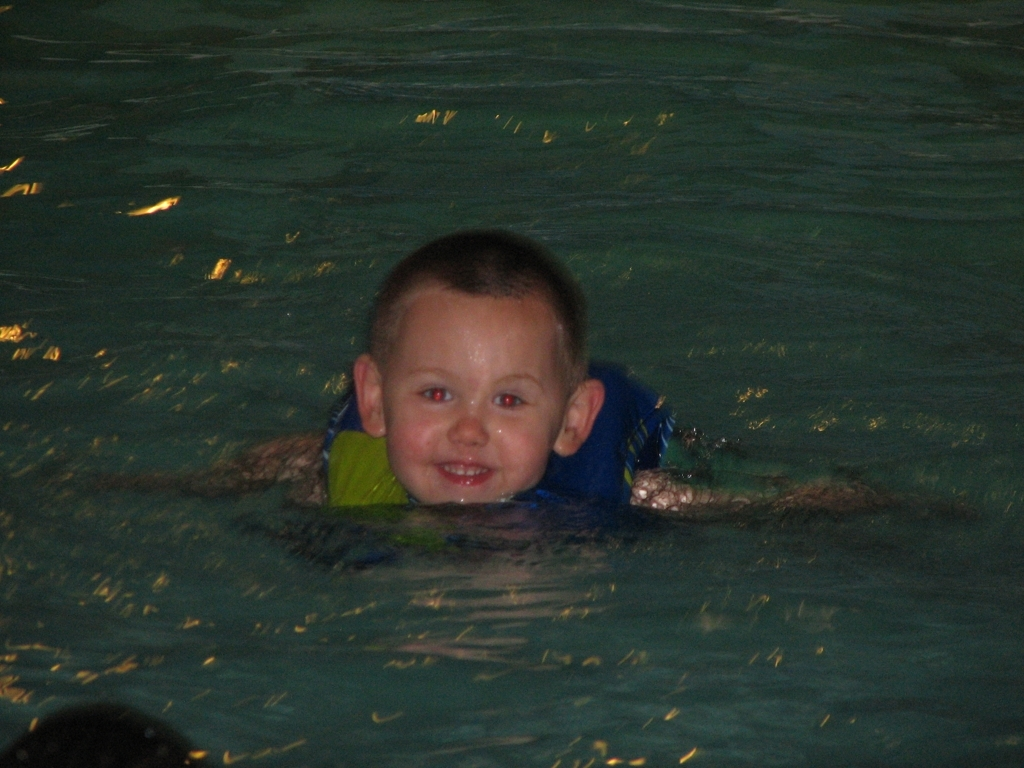How important is it for children to learn swimming at an early age? Learning to swim at an early age is very important for safety, as it equips children with vital survival skills in water. Additionally, it can contribute to their physical development and confidence. 